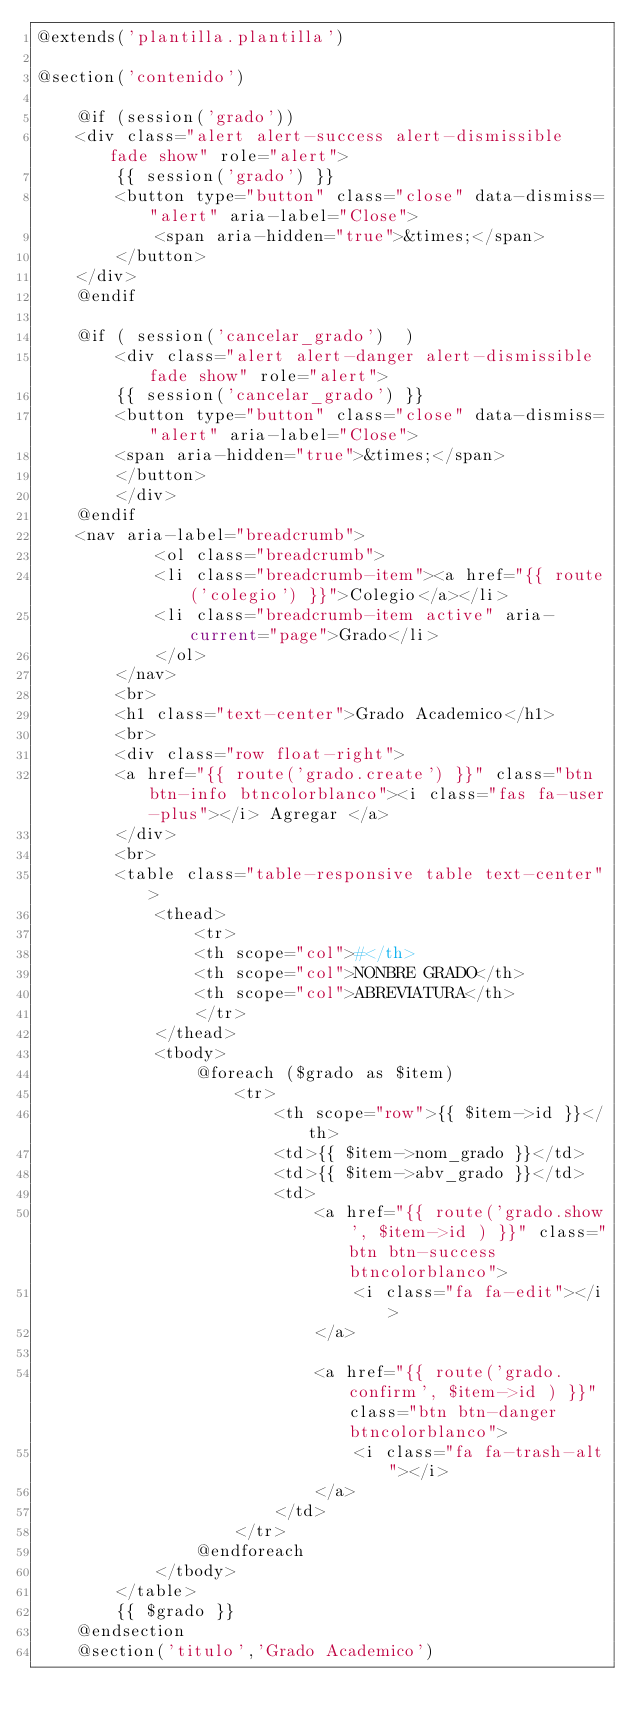Convert code to text. <code><loc_0><loc_0><loc_500><loc_500><_PHP_>@extends('plantilla.plantilla')

@section('contenido')

    @if (session('grado'))
    <div class="alert alert-success alert-dismissible fade show" role="alert">
        {{ session('grado') }}
        <button type="button" class="close" data-dismiss="alert" aria-label="Close">
            <span aria-hidden="true">&times;</span>
        </button>
    </div>
    @endif

    @if ( session('cancelar_grado')  )
        <div class="alert alert-danger alert-dismissible fade show" role="alert">
        {{ session('cancelar_grado') }}
        <button type="button" class="close" data-dismiss="alert" aria-label="Close">
        <span aria-hidden="true">&times;</span>
        </button>
        </div>
    @endif
    <nav aria-label="breadcrumb">
            <ol class="breadcrumb">
            <li class="breadcrumb-item"><a href="{{ route('colegio') }}">Colegio</a></li>
            <li class="breadcrumb-item active" aria-current="page">Grado</li>
            </ol>
        </nav>
        <br>
        <h1 class="text-center">Grado Academico</h1>
        <br>
        <div class="row float-right">
        <a href="{{ route('grado.create') }}" class="btn btn-info btncolorblanco"><i class="fas fa-user-plus"></i> Agregar </a>
        </div>
        <br>
        <table class="table-responsive table text-center">
            <thead>
                <tr>
                <th scope="col">#</th>
                <th scope="col">NONBRE GRADO</th>
                <th scope="col">ABREVIATURA</th>
                </tr>
            </thead>
            <tbody>
                @foreach ($grado as $item)
                    <tr>
                        <th scope="row">{{ $item->id }}</th>
                        <td>{{ $item->nom_grado }}</td>
                        <td>{{ $item->abv_grado }}</td>
                        <td>
                            <a href="{{ route('grado.show', $item->id ) }}" class="btn btn-success btncolorblanco">
                                <i class="fa fa-edit"></i>
                            </a>

                            <a href="{{ route('grado.confirm', $item->id ) }}" class="btn btn-danger btncolorblanco">
                                <i class="fa fa-trash-alt"></i>
                            </a>
                        </td>
                    </tr>
                @endforeach
            </tbody>
        </table>
        {{ $grado }}
    @endsection
    @section('titulo','Grado Academico')
</code> 